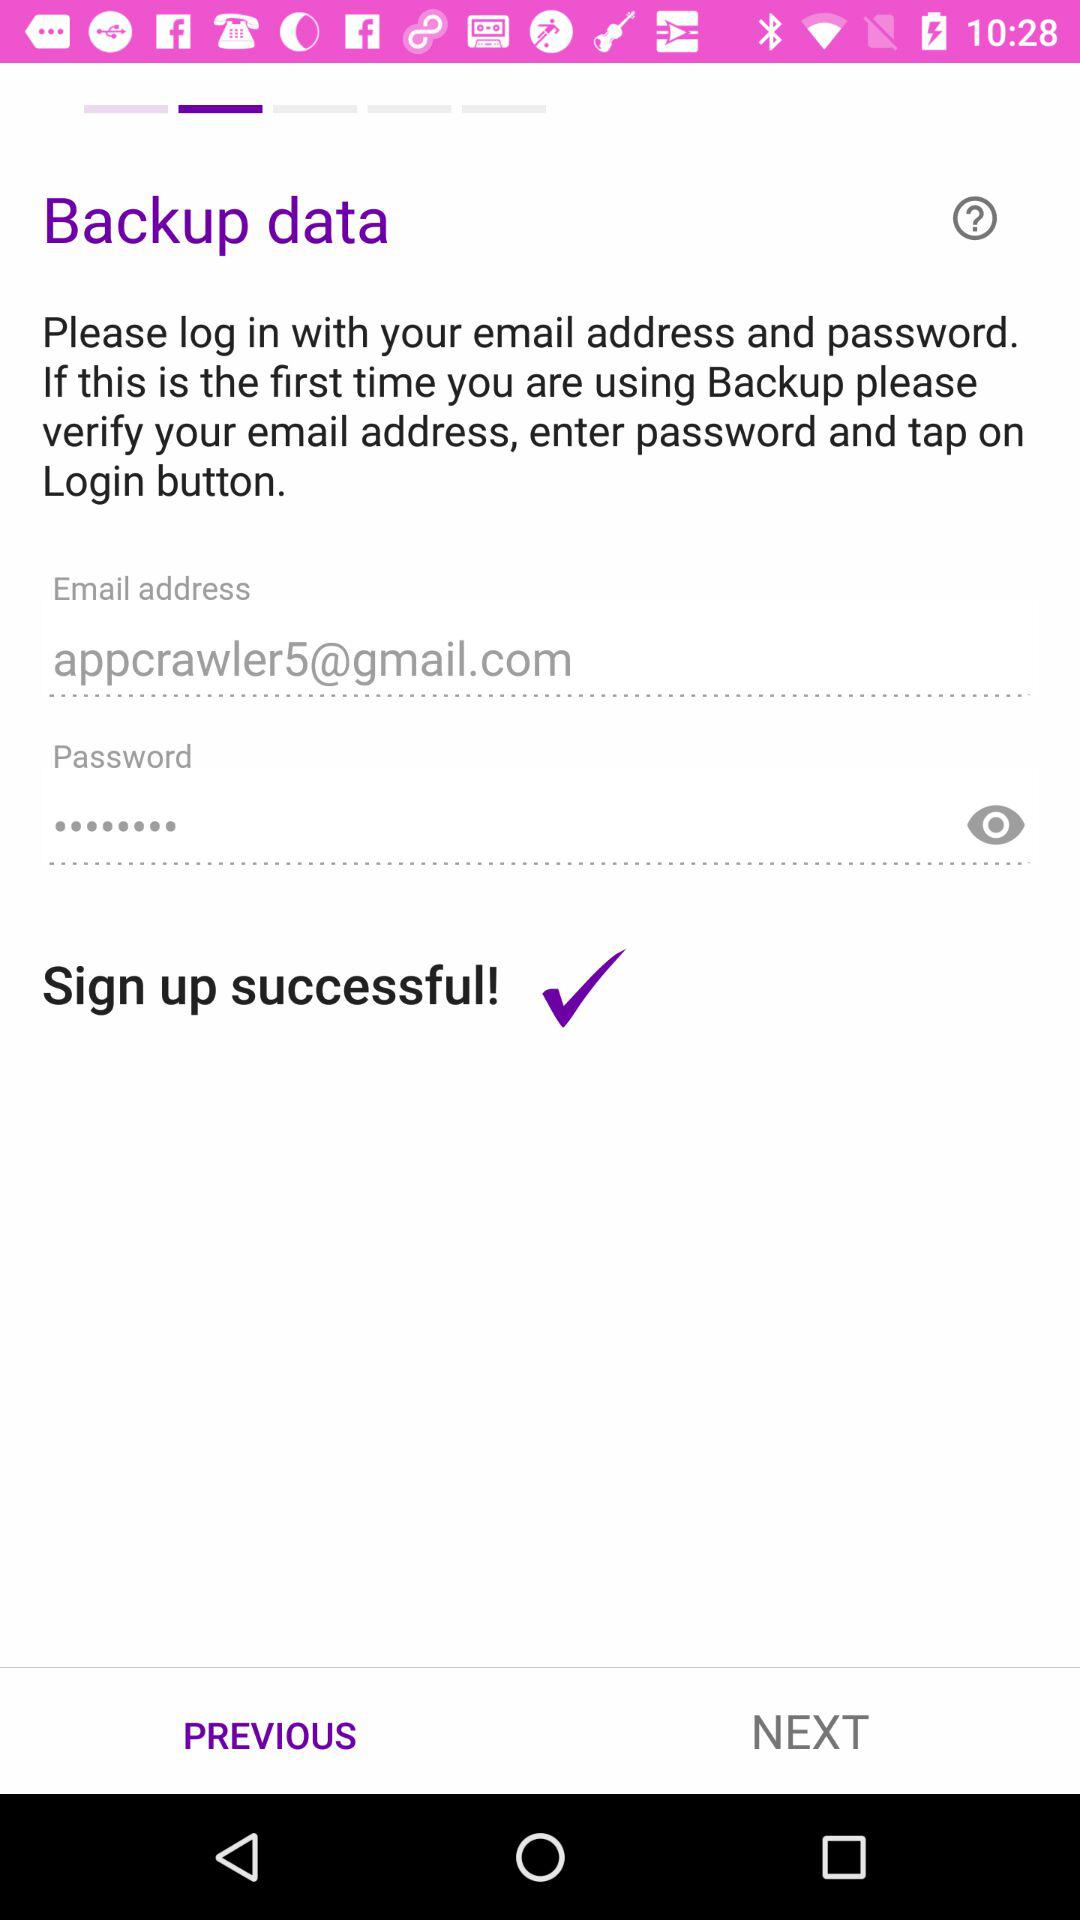How many characters are required for the password?
When the provided information is insufficient, respond with <no answer>. <no answer> 